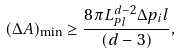<formula> <loc_0><loc_0><loc_500><loc_500>( \Delta A ) _ { \min } \geq \frac { 8 \pi L _ { P l } ^ { d - 2 } \Delta p _ { i } l } { ( d - 3 ) } ,</formula> 